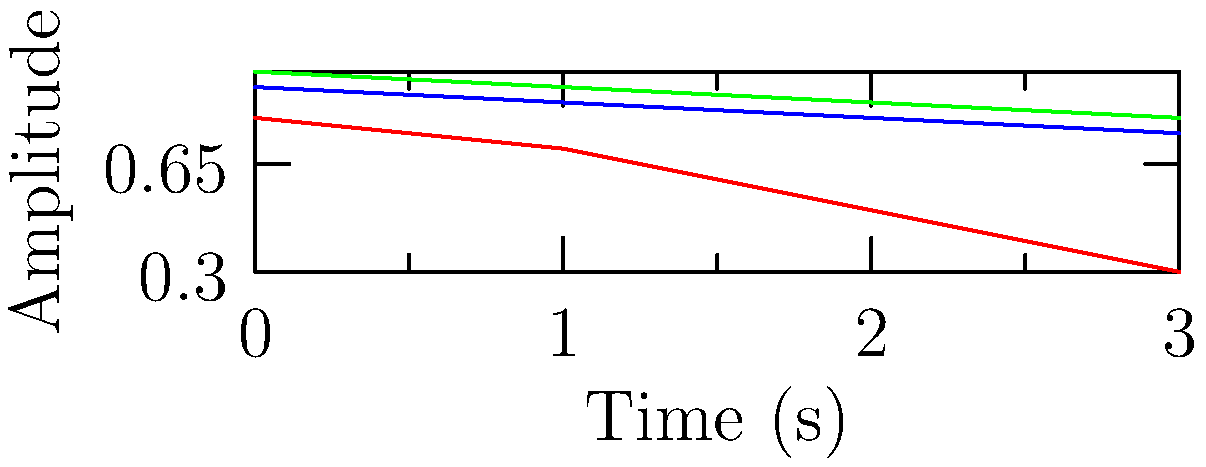Based on the graph showing the decay of drum sound over time for different materials, which material would be most suitable for creating a drum that produces sustained notes with minimal decay, potentially influencing the listener's perception of rhythm continuity? To answer this question, we need to analyze the decay patterns of each material:

1. Wood (red line):
   - Starts at amplitude 0.8
   - Decays rapidly to 0.3 by 3 seconds
   - Shows the steepest decay curve

2. Metal (blue line):
   - Starts at amplitude 0.9
   - Decays moderately to 0.75 by 3 seconds
   - Shows a more gradual decay than wood

3. Synthetic (green line):
   - Starts at amplitude 0.95
   - Decays slowly to 0.8 by 3 seconds
   - Shows the most gradual decay curve

For sustained notes with minimal decay, we want the material that maintains its amplitude the longest. This would influence the listener's perception of rhythm continuity by providing a more consistent sound over time.

The synthetic material (green line) shows the highest starting amplitude and the slowest decay rate, maintaining the highest amplitude throughout the 3-second period.
Answer: Synthetic 